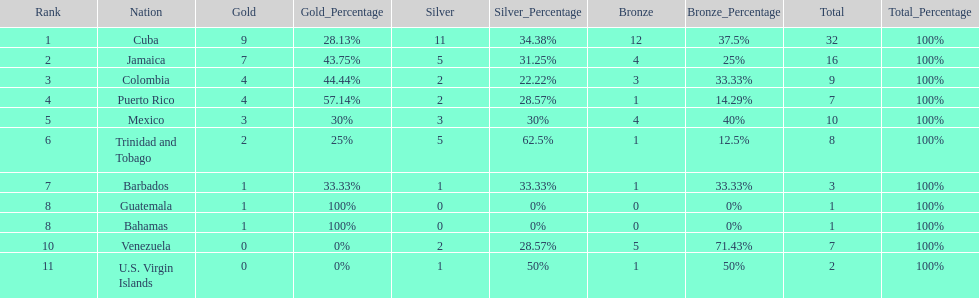Which country was awarded more than 5 silver medals? Cuba. 